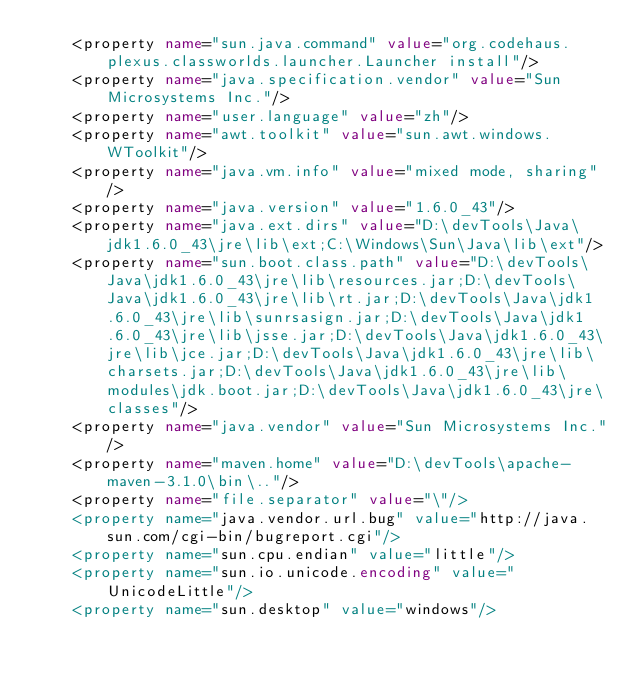<code> <loc_0><loc_0><loc_500><loc_500><_XML_>    <property name="sun.java.command" value="org.codehaus.plexus.classworlds.launcher.Launcher install"/>
    <property name="java.specification.vendor" value="Sun Microsystems Inc."/>
    <property name="user.language" value="zh"/>
    <property name="awt.toolkit" value="sun.awt.windows.WToolkit"/>
    <property name="java.vm.info" value="mixed mode, sharing"/>
    <property name="java.version" value="1.6.0_43"/>
    <property name="java.ext.dirs" value="D:\devTools\Java\jdk1.6.0_43\jre\lib\ext;C:\Windows\Sun\Java\lib\ext"/>
    <property name="sun.boot.class.path" value="D:\devTools\Java\jdk1.6.0_43\jre\lib\resources.jar;D:\devTools\Java\jdk1.6.0_43\jre\lib\rt.jar;D:\devTools\Java\jdk1.6.0_43\jre\lib\sunrsasign.jar;D:\devTools\Java\jdk1.6.0_43\jre\lib\jsse.jar;D:\devTools\Java\jdk1.6.0_43\jre\lib\jce.jar;D:\devTools\Java\jdk1.6.0_43\jre\lib\charsets.jar;D:\devTools\Java\jdk1.6.0_43\jre\lib\modules\jdk.boot.jar;D:\devTools\Java\jdk1.6.0_43\jre\classes"/>
    <property name="java.vendor" value="Sun Microsystems Inc."/>
    <property name="maven.home" value="D:\devTools\apache-maven-3.1.0\bin\.."/>
    <property name="file.separator" value="\"/>
    <property name="java.vendor.url.bug" value="http://java.sun.com/cgi-bin/bugreport.cgi"/>
    <property name="sun.cpu.endian" value="little"/>
    <property name="sun.io.unicode.encoding" value="UnicodeLittle"/>
    <property name="sun.desktop" value="windows"/></code> 